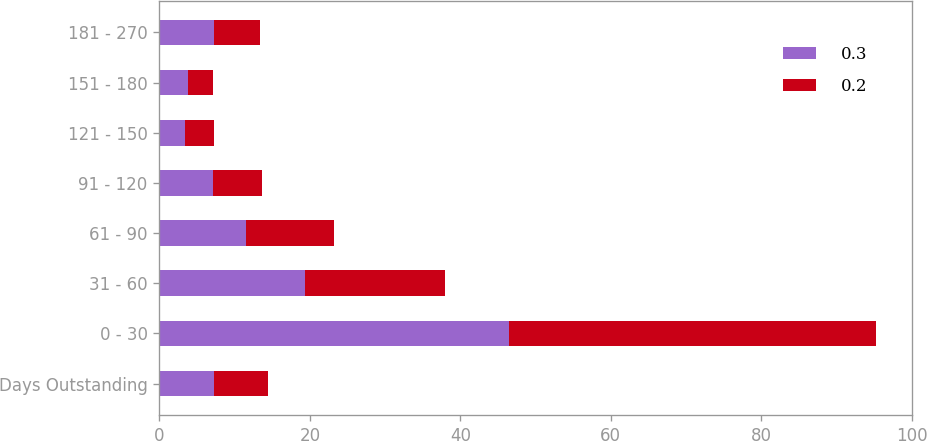<chart> <loc_0><loc_0><loc_500><loc_500><stacked_bar_chart><ecel><fcel>Days Outstanding<fcel>0 - 30<fcel>31 - 60<fcel>61 - 90<fcel>91 - 120<fcel>121 - 150<fcel>151 - 180<fcel>181 - 270<nl><fcel>0.3<fcel>7.2<fcel>46.4<fcel>19.3<fcel>11.5<fcel>7.1<fcel>3.4<fcel>3.8<fcel>7.3<nl><fcel>0.2<fcel>7.2<fcel>48.9<fcel>18.6<fcel>11.7<fcel>6.5<fcel>3.9<fcel>3.3<fcel>6.1<nl></chart> 